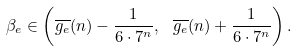<formula> <loc_0><loc_0><loc_500><loc_500>\beta _ { e } \in \left ( \overline { g _ { e } } ( n ) - \frac { 1 } { 6 \cdot 7 ^ { n } } , \ \overline { g _ { e } } ( n ) + \frac { 1 } { 6 \cdot 7 ^ { n } } \right ) .</formula> 